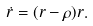<formula> <loc_0><loc_0><loc_500><loc_500>\dot { r } = ( r - \rho ) r .</formula> 